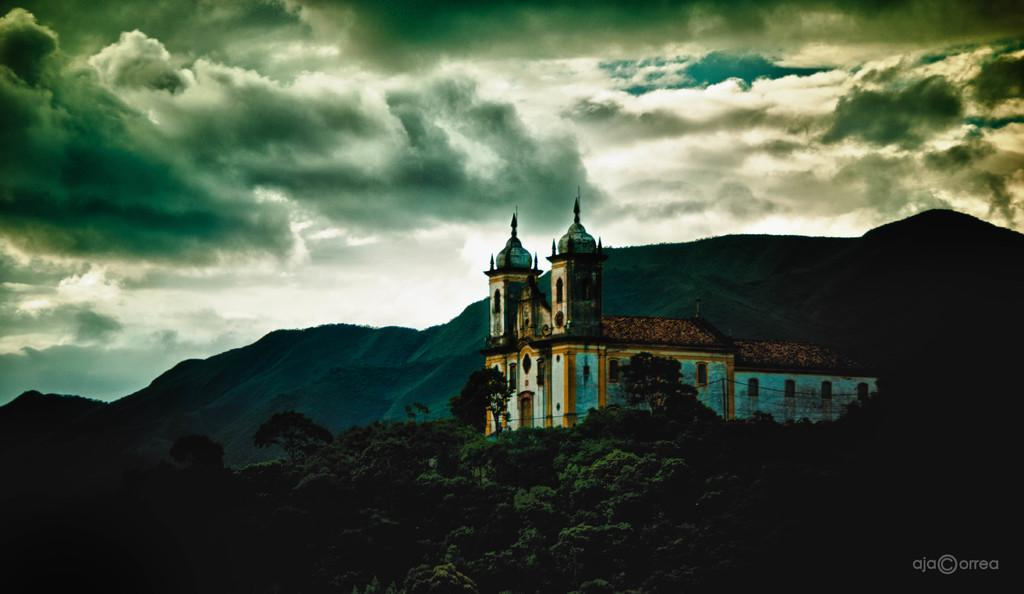What type of structure is visible in the image? There is a building in the image. What other natural elements can be seen in the image? There are trees and mountains visible in the image. What part of the building can be seen in the image? There are windows in the image. What is visible in the background of the image? The sky is visible in the background of the image. What is the condition of the sky in the image? Clouds are present in the sky. How does the building care for the trees in the image? The building does not care for the trees in the image; they are separate entities. 